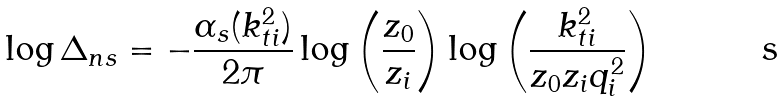Convert formula to latex. <formula><loc_0><loc_0><loc_500><loc_500>\log \Delta _ { n s } = - \frac { \alpha _ { s } ( k ^ { 2 } _ { t i } ) } { 2 \pi } \log \left ( \frac { z _ { 0 } } { z _ { i } } \right ) \log \left ( \frac { k ^ { 2 } _ { t i } } { z _ { 0 } z _ { i } q ^ { 2 } _ { i } } \right )</formula> 